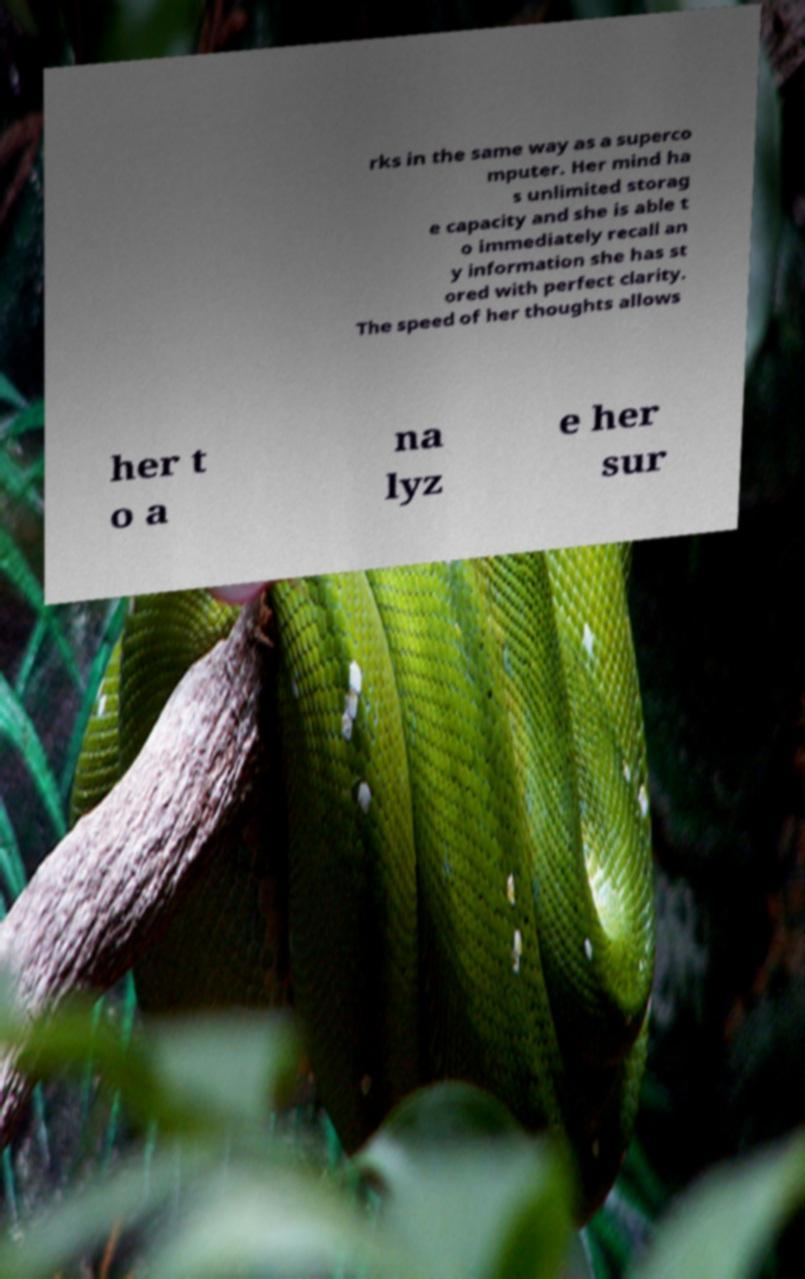Could you assist in decoding the text presented in this image and type it out clearly? rks in the same way as a superco mputer. Her mind ha s unlimited storag e capacity and she is able t o immediately recall an y information she has st ored with perfect clarity. The speed of her thoughts allows her t o a na lyz e her sur 